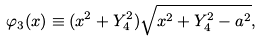Convert formula to latex. <formula><loc_0><loc_0><loc_500><loc_500>\varphi _ { 3 } ( x ) \equiv ( x ^ { 2 } + Y _ { 4 } ^ { 2 } ) \sqrt { x ^ { 2 } + Y _ { 4 } ^ { 2 } - a ^ { 2 } } ,</formula> 